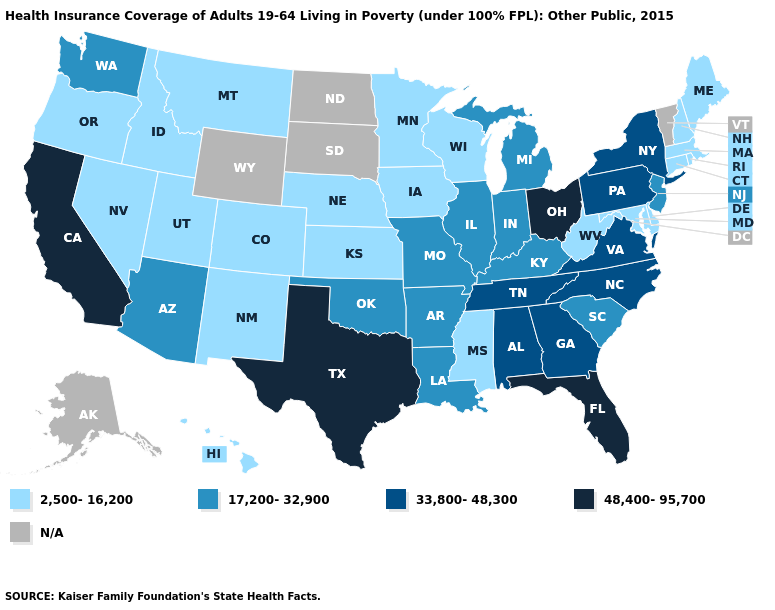How many symbols are there in the legend?
Concise answer only. 5. Name the states that have a value in the range 33,800-48,300?
Give a very brief answer. Alabama, Georgia, New York, North Carolina, Pennsylvania, Tennessee, Virginia. What is the value of New Mexico?
Give a very brief answer. 2,500-16,200. Name the states that have a value in the range 33,800-48,300?
Be succinct. Alabama, Georgia, New York, North Carolina, Pennsylvania, Tennessee, Virginia. What is the value of Virginia?
Keep it brief. 33,800-48,300. Which states have the highest value in the USA?
Short answer required. California, Florida, Ohio, Texas. Name the states that have a value in the range 17,200-32,900?
Be succinct. Arizona, Arkansas, Illinois, Indiana, Kentucky, Louisiana, Michigan, Missouri, New Jersey, Oklahoma, South Carolina, Washington. Among the states that border Iowa , which have the highest value?
Give a very brief answer. Illinois, Missouri. Name the states that have a value in the range 2,500-16,200?
Concise answer only. Colorado, Connecticut, Delaware, Hawaii, Idaho, Iowa, Kansas, Maine, Maryland, Massachusetts, Minnesota, Mississippi, Montana, Nebraska, Nevada, New Hampshire, New Mexico, Oregon, Rhode Island, Utah, West Virginia, Wisconsin. What is the value of Virginia?
Short answer required. 33,800-48,300. Which states have the lowest value in the USA?
Answer briefly. Colorado, Connecticut, Delaware, Hawaii, Idaho, Iowa, Kansas, Maine, Maryland, Massachusetts, Minnesota, Mississippi, Montana, Nebraska, Nevada, New Hampshire, New Mexico, Oregon, Rhode Island, Utah, West Virginia, Wisconsin. What is the highest value in states that border Colorado?
Answer briefly. 17,200-32,900. 